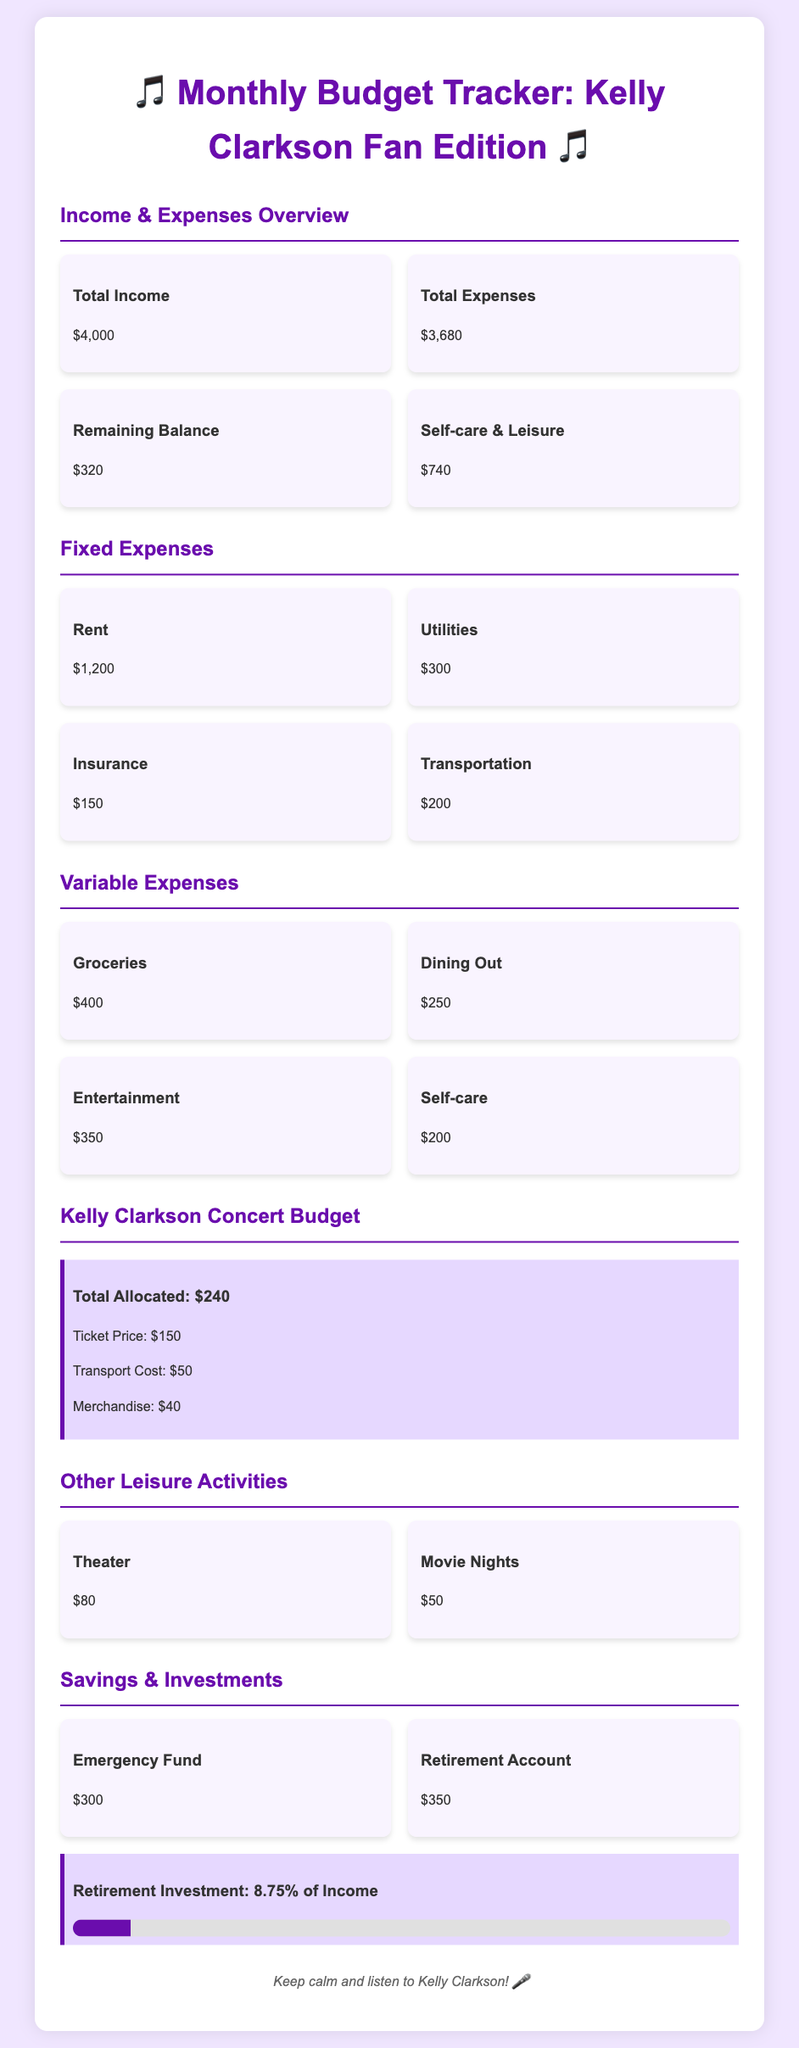What is the total income? The total income is provided in the "Income & Expenses Overview" section, which states the total income is $4,000.
Answer: $4,000 What is the remaining balance? The remaining balance is calculated as total income minus total expenses, and it is listed as $320.
Answer: $320 How much is allocated for Kelly Clarkson concerts? The specific section titled "Kelly Clarkson Concert Budget" states that the total allocated for concerts is $240.
Answer: $240 What is the ticket price for the concert? The ticket price is specified in the "Kelly Clarkson Concert Budget" section as $150.
Answer: $150 What percentage of income is allocated to the retirement investment? The document mentions that the retirement investment is 8.75% of total income.
Answer: 8.75% What is the total amount spent on self-care? The total amount for self-care is detailed under "Variable Expenses" as $200.
Answer: $200 What are the fixed expenses related to utilities? The fixed expenses section lists utilities, which amount to $300.
Answer: $300 What is the total cost for movie nights? The cost for movie nights is specified in the "Other Leisure Activities" section as $50.
Answer: $50 How much is budgeted for theater activities? The theater expense is also listed under "Other Leisure Activities" and totals $80.
Answer: $80 